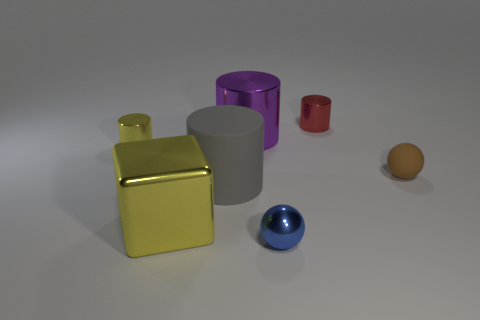Add 1 tiny red cylinders. How many objects exist? 8 Subtract all balls. How many objects are left? 5 Subtract 0 red spheres. How many objects are left? 7 Subtract all big gray things. Subtract all tiny shiny balls. How many objects are left? 5 Add 1 large cylinders. How many large cylinders are left? 3 Add 4 small blue objects. How many small blue objects exist? 5 